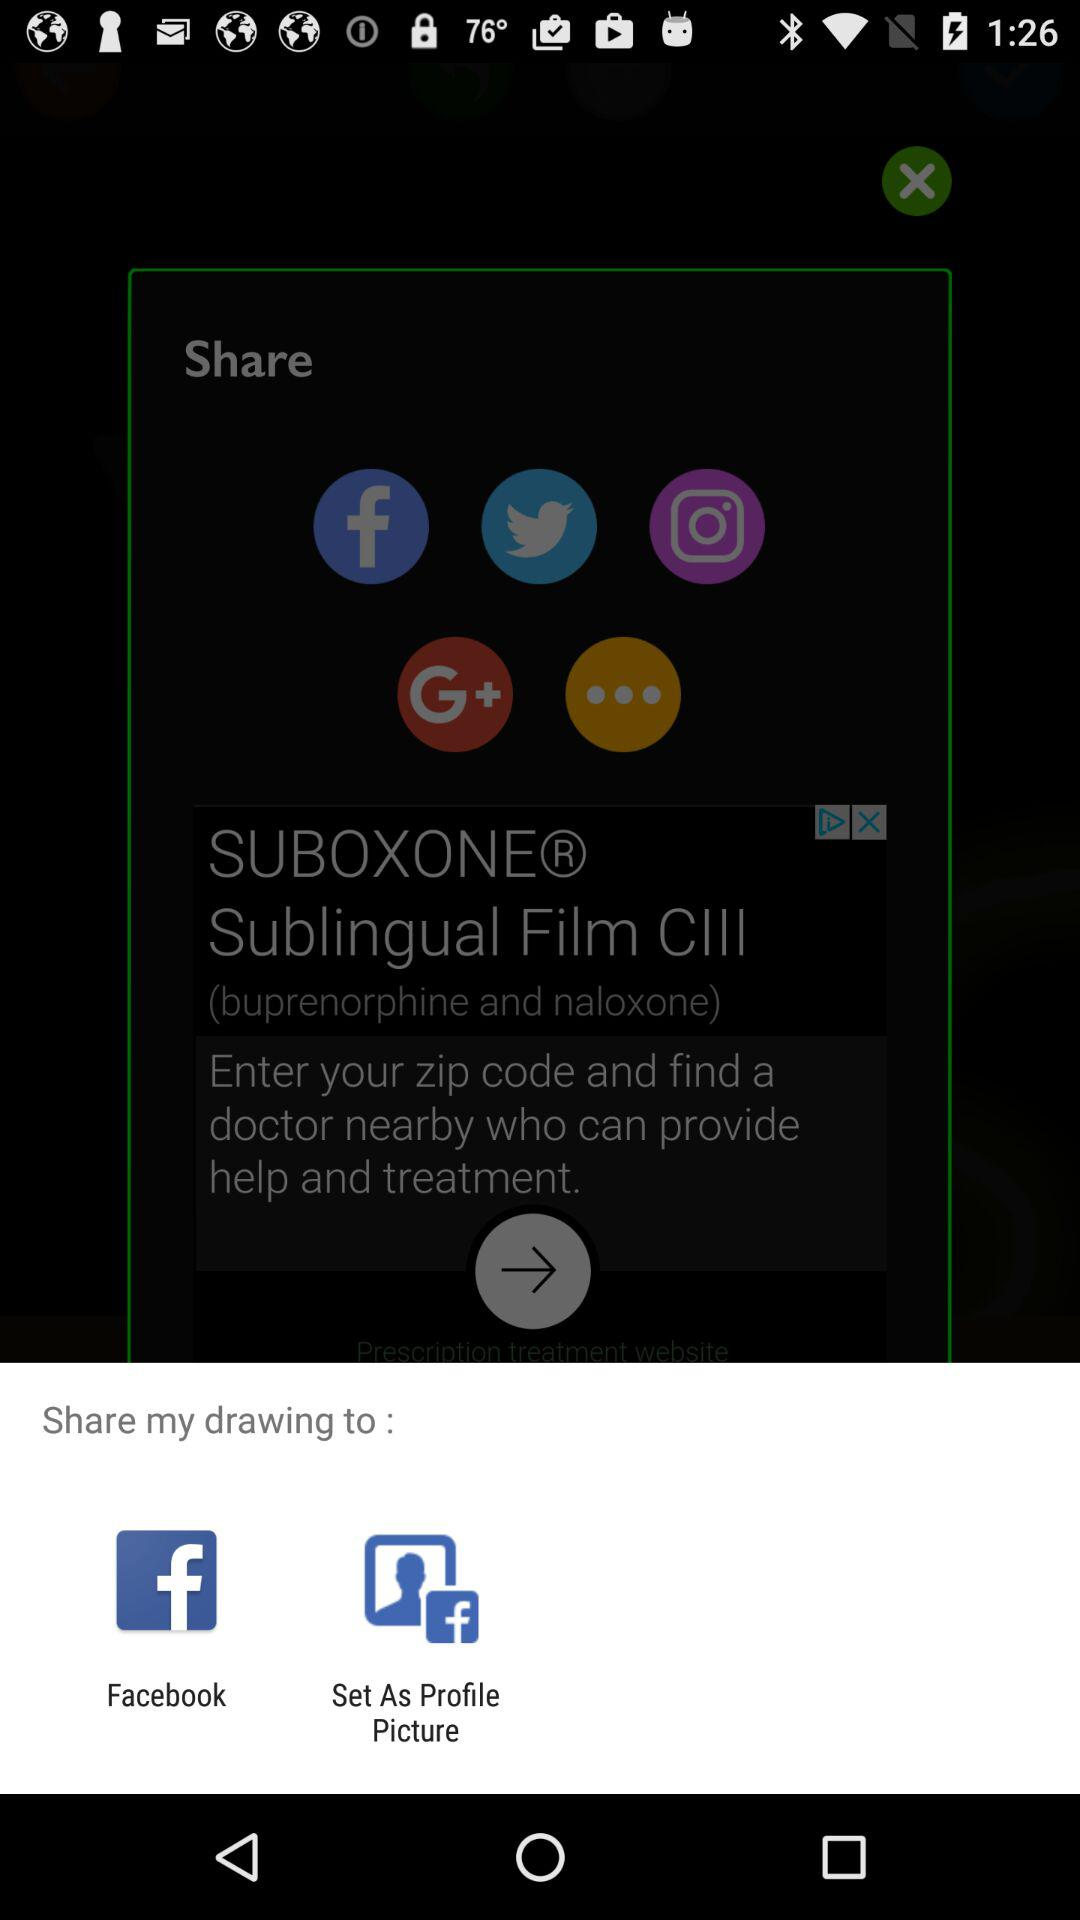What applications can be used to share the drawing? The application is "Facebook". 